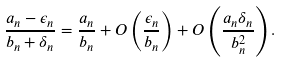<formula> <loc_0><loc_0><loc_500><loc_500>\frac { a _ { n } - \epsilon _ { n } } { b _ { n } + \delta _ { n } } = \frac { a _ { n } } { b _ { n } } + O \left ( \frac { \epsilon _ { n } } { b _ { n } } \right ) + O \left ( \frac { a _ { n } \delta _ { n } } { b _ { n } ^ { 2 } } \right ) .</formula> 